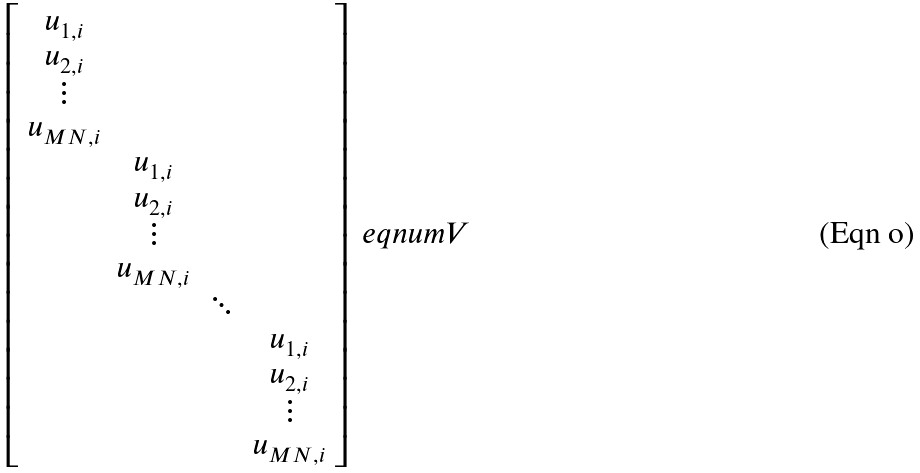Convert formula to latex. <formula><loc_0><loc_0><loc_500><loc_500>\left [ \begin{array} { c c c c } u _ { 1 , i } & & & \\ u _ { 2 , i } & & & \\ \vdots & & & \\ u _ { M N , i } & & & \\ & u _ { 1 , i } & & \\ & u _ { 2 , i } & & \\ & \vdots & & \\ & u _ { M N , i } & & \\ & & \ddots & \\ & & & u _ { 1 , i } \\ & & & u _ { 2 , i } \\ & & & \vdots \\ & & & u _ { M N , i } \end{array} \right ] \ e q n u m { V }</formula> 